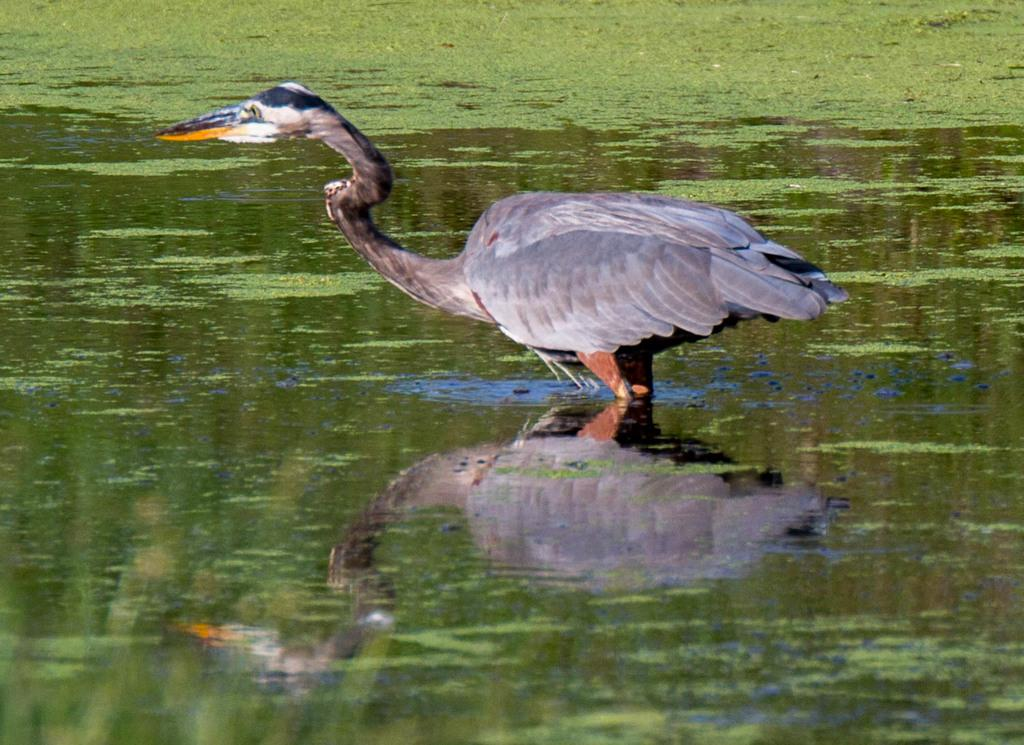What type of animal is in the image? There is a swan in the image. Where is the swan located in the image? The swan is on the water. What type of show is the swan performing in the image? There is no show or performance involving the swan in the image. How many spiders can be seen on the swan in the image? There are no spiders present in the image, and therefore none can be seen on the swan. 